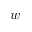Convert formula to latex. <formula><loc_0><loc_0><loc_500><loc_500>w</formula> 